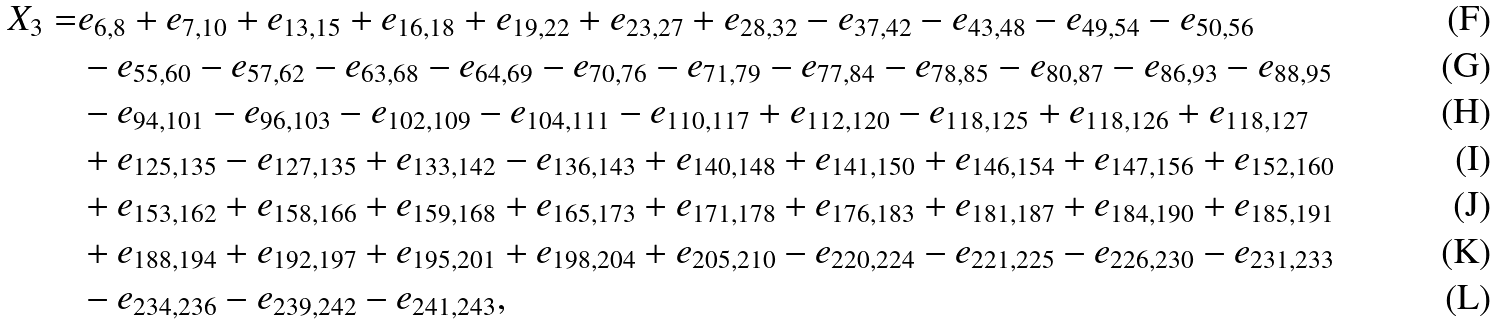Convert formula to latex. <formula><loc_0><loc_0><loc_500><loc_500>X _ { 3 } = & e _ { 6 , 8 } + e _ { 7 , 1 0 } + e _ { 1 3 , 1 5 } + e _ { 1 6 , 1 8 } + e _ { 1 9 , 2 2 } + e _ { 2 3 , 2 7 } + e _ { 2 8 , 3 2 } - e _ { 3 7 , 4 2 } - e _ { 4 3 , 4 8 } - e _ { 4 9 , 5 4 } - e _ { 5 0 , 5 6 } \\ & - e _ { 5 5 , 6 0 } - e _ { 5 7 , 6 2 } - e _ { 6 3 , 6 8 } - e _ { 6 4 , 6 9 } - e _ { 7 0 , 7 6 } - e _ { 7 1 , 7 9 } - e _ { 7 7 , 8 4 } - e _ { 7 8 , 8 5 } - e _ { 8 0 , 8 7 } - e _ { 8 6 , 9 3 } - e _ { 8 8 , 9 5 } \\ & - e _ { 9 4 , 1 0 1 } - e _ { 9 6 , 1 0 3 } - e _ { 1 0 2 , 1 0 9 } - e _ { 1 0 4 , 1 1 1 } - e _ { 1 1 0 , 1 1 7 } + e _ { 1 1 2 , 1 2 0 } - e _ { 1 1 8 , 1 2 5 } + e _ { 1 1 8 , 1 2 6 } + e _ { 1 1 8 , 1 2 7 } \\ & + e _ { 1 2 5 , 1 3 5 } - e _ { 1 2 7 , 1 3 5 } + e _ { 1 3 3 , 1 4 2 } - e _ { 1 3 6 , 1 4 3 } + e _ { 1 4 0 , 1 4 8 } + e _ { 1 4 1 , 1 5 0 } + e _ { 1 4 6 , 1 5 4 } + e _ { 1 4 7 , 1 5 6 } + e _ { 1 5 2 , 1 6 0 } \\ & + e _ { 1 5 3 , 1 6 2 } + e _ { 1 5 8 , 1 6 6 } + e _ { 1 5 9 , 1 6 8 } + e _ { 1 6 5 , 1 7 3 } + e _ { 1 7 1 , 1 7 8 } + e _ { 1 7 6 , 1 8 3 } + e _ { 1 8 1 , 1 8 7 } + e _ { 1 8 4 , 1 9 0 } + e _ { 1 8 5 , 1 9 1 } \\ & + e _ { 1 8 8 , 1 9 4 } + e _ { 1 9 2 , 1 9 7 } + e _ { 1 9 5 , 2 0 1 } + e _ { 1 9 8 , 2 0 4 } + e _ { 2 0 5 , 2 1 0 } - e _ { 2 2 0 , 2 2 4 } - e _ { 2 2 1 , 2 2 5 } - e _ { 2 2 6 , 2 3 0 } - e _ { 2 3 1 , 2 3 3 } \\ & - e _ { 2 3 4 , 2 3 6 } - e _ { 2 3 9 , 2 4 2 } - e _ { 2 4 1 , 2 4 3 } ,</formula> 